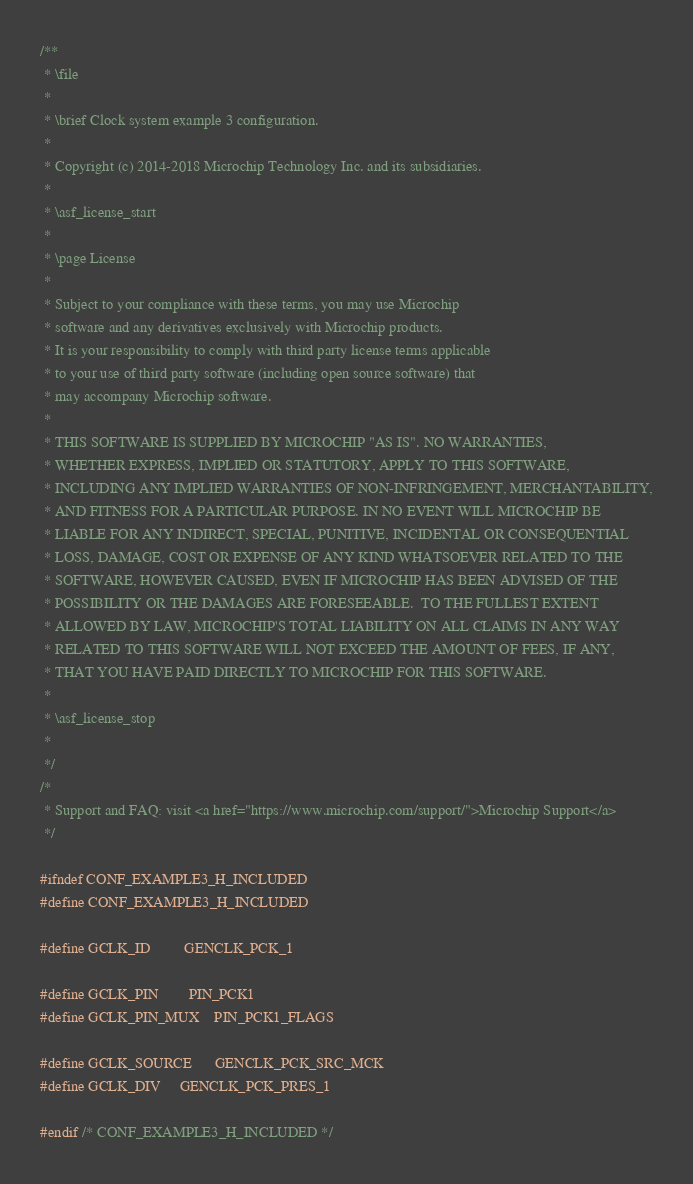<code> <loc_0><loc_0><loc_500><loc_500><_C_>/**
 * \file
 *
 * \brief Clock system example 3 configuration.
 *
 * Copyright (c) 2014-2018 Microchip Technology Inc. and its subsidiaries.
 *
 * \asf_license_start
 *
 * \page License
 *
 * Subject to your compliance with these terms, you may use Microchip
 * software and any derivatives exclusively with Microchip products.
 * It is your responsibility to comply with third party license terms applicable
 * to your use of third party software (including open source software) that
 * may accompany Microchip software.
 *
 * THIS SOFTWARE IS SUPPLIED BY MICROCHIP "AS IS". NO WARRANTIES,
 * WHETHER EXPRESS, IMPLIED OR STATUTORY, APPLY TO THIS SOFTWARE,
 * INCLUDING ANY IMPLIED WARRANTIES OF NON-INFRINGEMENT, MERCHANTABILITY,
 * AND FITNESS FOR A PARTICULAR PURPOSE. IN NO EVENT WILL MICROCHIP BE
 * LIABLE FOR ANY INDIRECT, SPECIAL, PUNITIVE, INCIDENTAL OR CONSEQUENTIAL
 * LOSS, DAMAGE, COST OR EXPENSE OF ANY KIND WHATSOEVER RELATED TO THE
 * SOFTWARE, HOWEVER CAUSED, EVEN IF MICROCHIP HAS BEEN ADVISED OF THE
 * POSSIBILITY OR THE DAMAGES ARE FORESEEABLE.  TO THE FULLEST EXTENT
 * ALLOWED BY LAW, MICROCHIP'S TOTAL LIABILITY ON ALL CLAIMS IN ANY WAY
 * RELATED TO THIS SOFTWARE WILL NOT EXCEED THE AMOUNT OF FEES, IF ANY,
 * THAT YOU HAVE PAID DIRECTLY TO MICROCHIP FOR THIS SOFTWARE.
 *
 * \asf_license_stop
 *
 */
/*
 * Support and FAQ: visit <a href="https://www.microchip.com/support/">Microchip Support</a>
 */

#ifndef CONF_EXAMPLE3_H_INCLUDED
#define CONF_EXAMPLE3_H_INCLUDED

#define GCLK_ID         GENCLK_PCK_1

#define GCLK_PIN        PIN_PCK1
#define GCLK_PIN_MUX    PIN_PCK1_FLAGS

#define GCLK_SOURCE		GENCLK_PCK_SRC_MCK
#define GCLK_DIV		GENCLK_PCK_PRES_1

#endif /* CONF_EXAMPLE3_H_INCLUDED */
</code> 